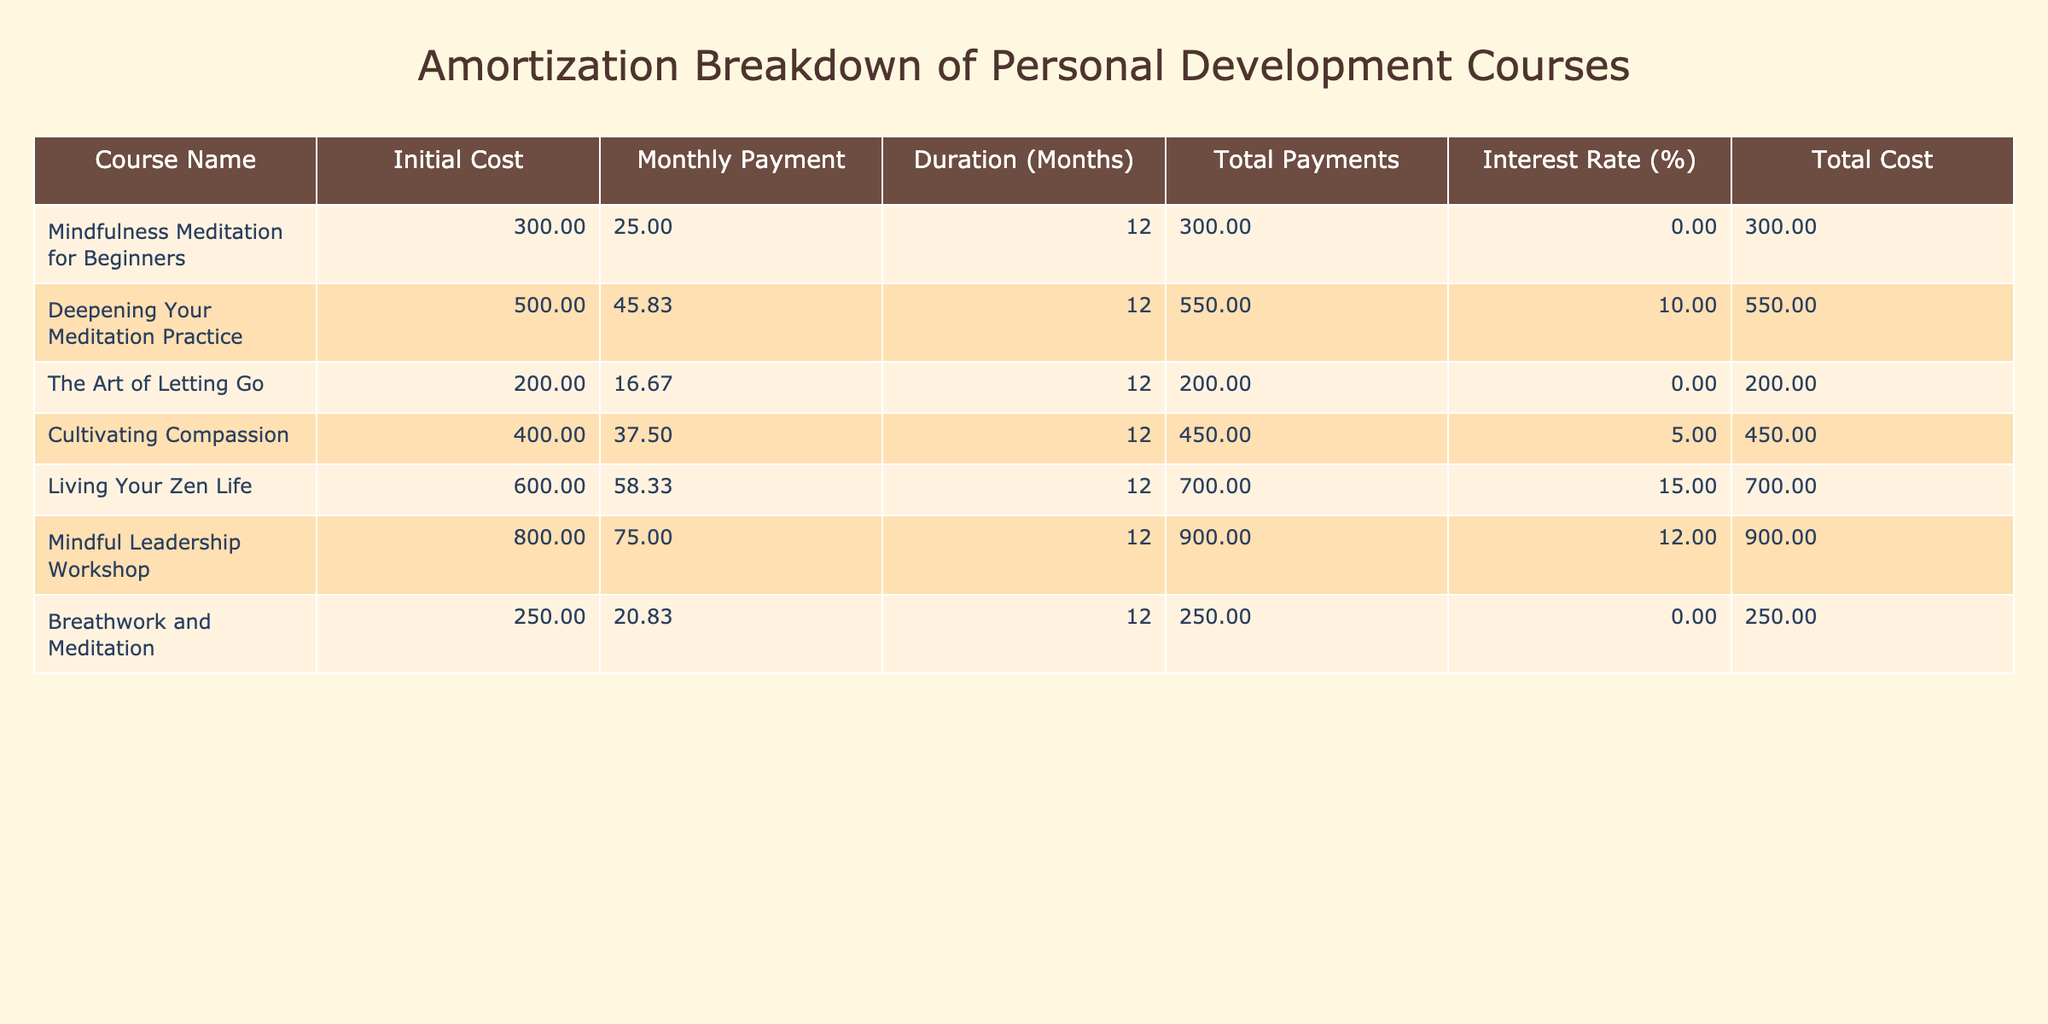What is the total cost of the "Deepening Your Meditation Practice" course? The total cost for the "Deepening Your Meditation Practice" course is indicated in the table under the "Total Cost" column. By looking at that specific row, we see the value is 550.00.
Answer: 550.00 How much is the monthly payment for the "Living Your Zen Life" course? In the table, the monthly payment for the "Living Your Zen Life" course is stated in the "Monthly Payment" column. Referring to that row, we can find the value, which is 58.33.
Answer: 58.33 Which course has the highest total payments? To find this, we look at the "Total Payments" column, identify the maximum value, and find the corresponding course name. The highest total payment is 900.00, which corresponds to the "Mindful Leadership Workshop."
Answer: Mindful Leadership Workshop What is the average initial cost of all courses? We start by summarizing the initial costs from the "Initial Cost" column: 300 + 500 + 200 + 400 + 600 + 800 + 250 = 3050. There are seven courses, so we divide the total by 7 to find the average: 3050 / 7 = approximately 435.71.
Answer: 435.71 Is the total cost for the "The Art of Letting Go" course lower than 250? We check the total cost for "The Art of Letting Go" in the "Total Cost" column, which is 200.00. Since 200.00 is indeed lower than 250, we answer affirmatively.
Answer: Yes Which course has the lowest interest rate compared to others? We examine the "Interest Rate (%)" column to identify the minimum percentage. The courses "Mindfulness Meditation for Beginners," "The Art of Letting Go," and "Breathwork and Meditation" all have an interest rate of 0.00, making them the courses with the lowest interest rate.
Answer: Mindfulness Meditation for Beginners, The Art of Letting Go, Breathwork and Meditation What is the difference between the total costs of "Cultivating Compassion" and "Living Your Zen Life"? We look up the total costs in the "Total Cost" column for each. "Cultivating Compassion" is 450.00 and "Living Your Zen Life" is 700.00. The difference is calculated as 700 - 450 = 250.00.
Answer: 250.00 How many courses have a monthly payment of 25.00 or more? By examining the "Monthly Payment" column, we count each course with a monthly payment of at least 25.00. The relevant courses are "Mindfulness Meditation for Beginners," "Deepening Your Meditation Practice," "Cultivating Compassion," "Living Your Zen Life," "Mindful Leadership Workshop," and "Breathwork and Meditation," totaling 6 courses.
Answer: 6 What is the total initial cost of all courses listed? We sum all the values in the "Initial Cost" column: 300 + 500 + 200 + 400 + 600 + 800 + 250 = 3050. This value represents the total initial cost of all courses.
Answer: 3050 